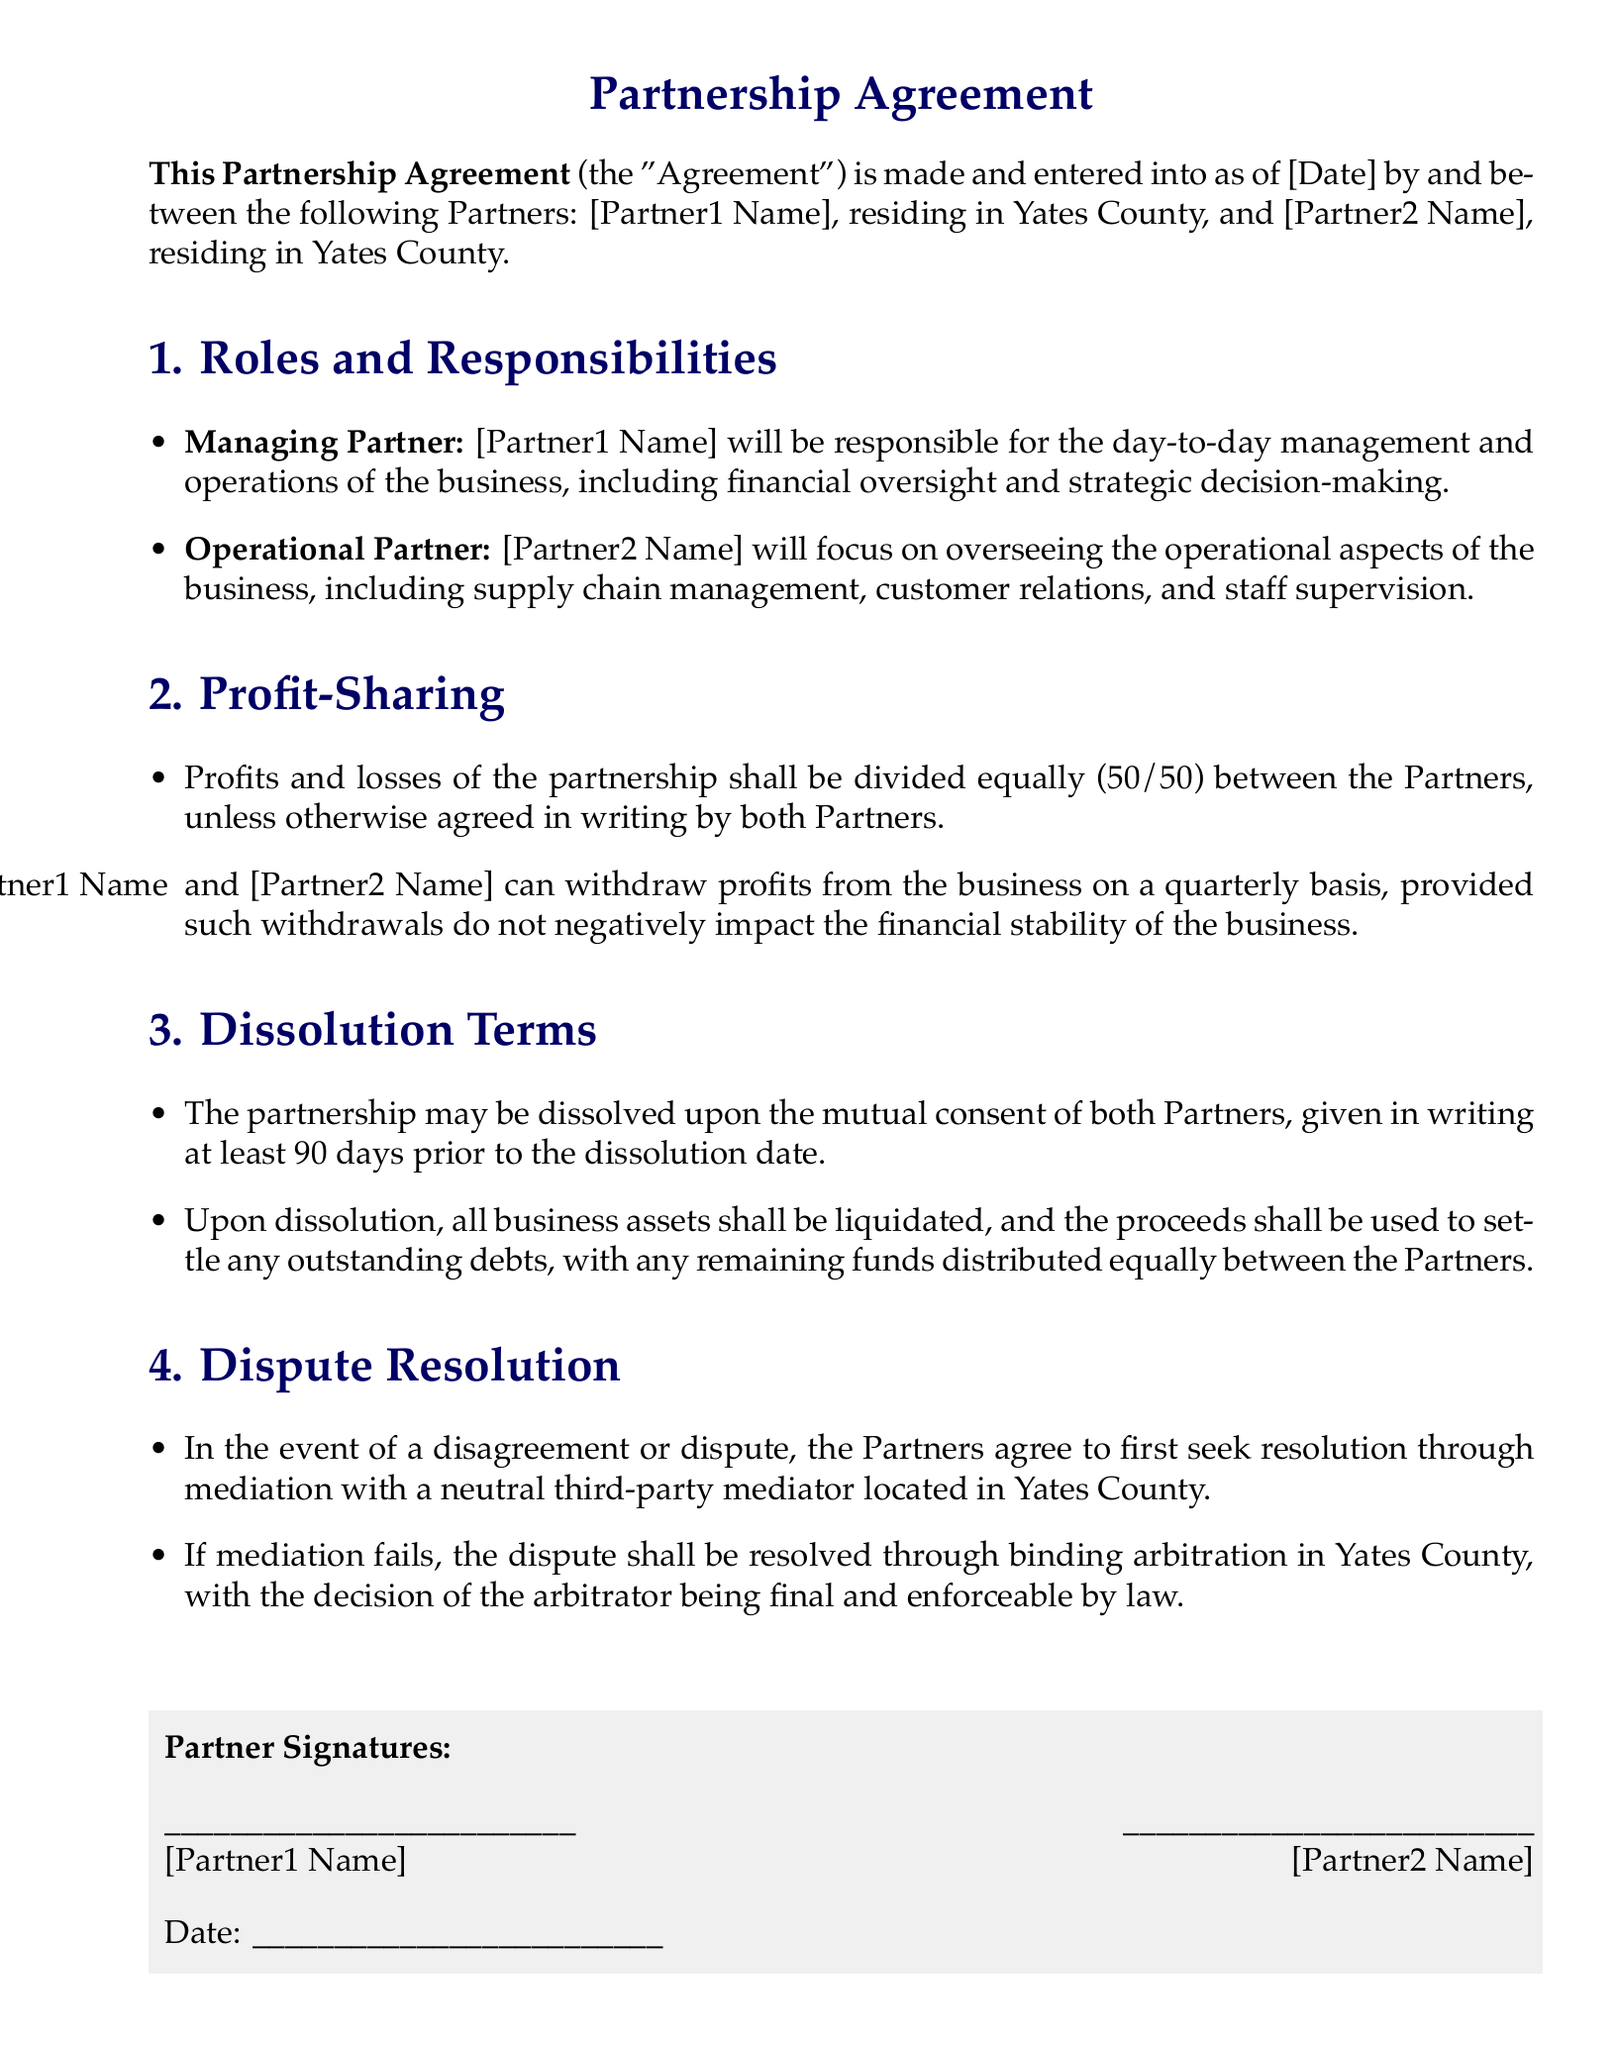What is the title of the document? The title is prominently displayed at the top of the document.
Answer: Partnership Agreement Who is the Managing Partner? The role of Managing Partner is explicitly mentioned in the roles and responsibilities section.
Answer: [Partner1 Name] What is the profit-sharing ratio? The document outlines how profits and losses are to be split between the partners.
Answer: 50/50 What is the required notice period for dissolution? This information is outlined in the dissolution terms section.
Answer: 90 days How will disputes be resolved first? The document specifies the initial method for dispute resolution.
Answer: Mediation What happens to the business assets upon dissolution? This is detailed in the dissolution terms section, explaining how assets are to be handled.
Answer: Liquidated Who will oversee operational aspects? The document explicitly states the responsibilities of the partners.
Answer: [Partner2 Name] What must happen for the partnership to be dissolved? The conditions for dissolving the partnership are mentioned in the dissolution terms.
Answer: Mutual consent What is the location for arbitration? The document specifies the geographic location for arbitration if mediation fails.
Answer: Yates County How often can partners withdraw profits? The document indicates the frequency of profit withdrawals allowed.
Answer: Quarterly 